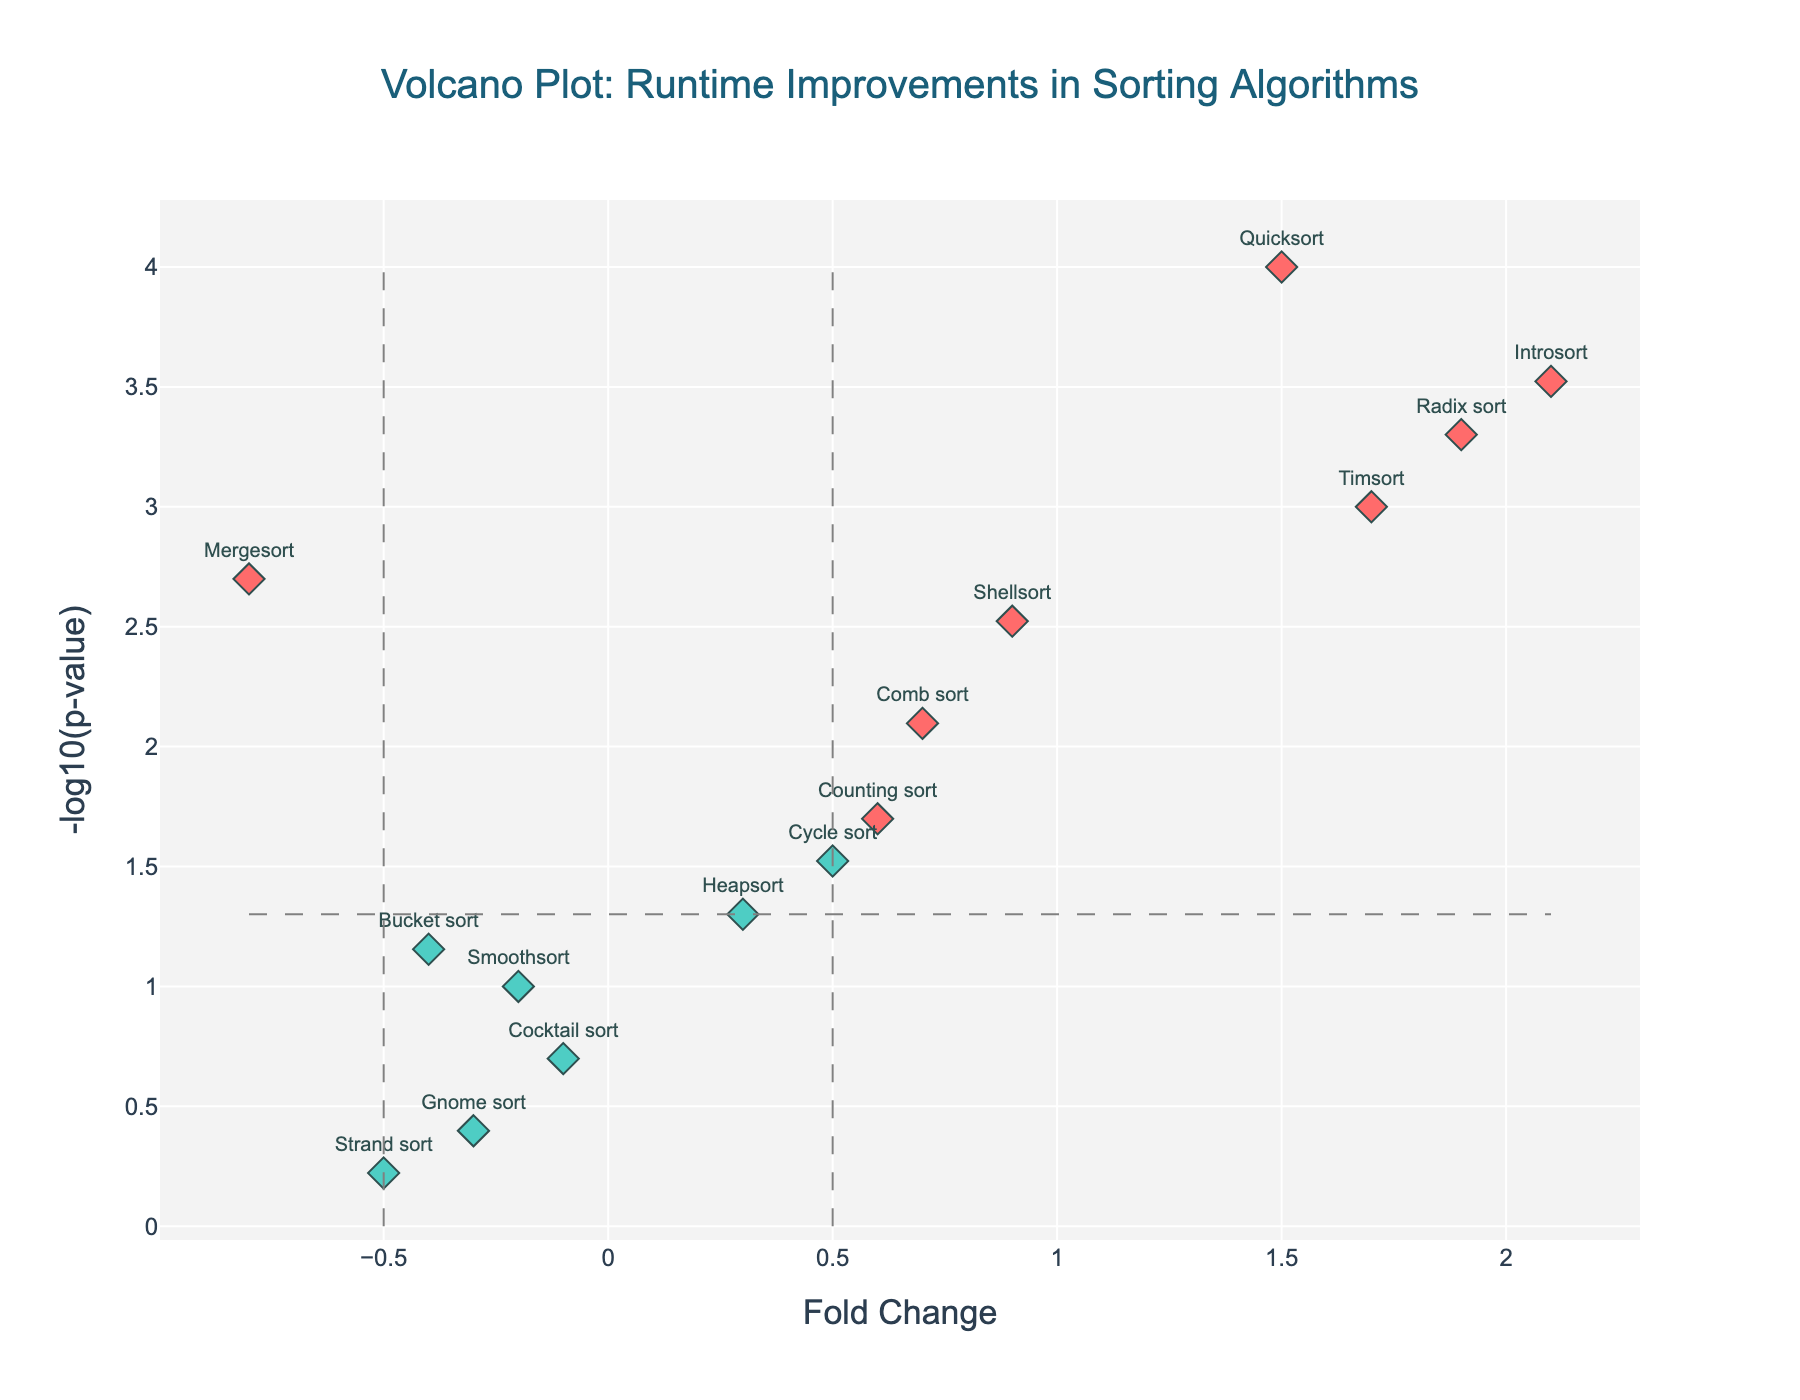What is the title of the figure? The title of the figure is displayed at the top and reads "Volcano Plot: Runtime Improvements in Sorting Algorithms".
Answer: Volcano Plot: Runtime Improvements in Sorting Algorithms What is shown on the x-axis and y-axis? The x-axis is labeled "Fold Change", which shows the change in algorithm run times. The y-axis is labeled "-log10(p-value)", indicating the statistical significance of those changes.
Answer: Fold Change and -log10(p-value) Which algorithm has the highest fold change? To determine this, we look at the scatter points and identify the algorithm with the highest x-axis value, which represents fold change.
Answer: Introsort How many algorithms are considered significant according to the plot? Algorithms are considered 'Significant' if their p-value is less than 0.05 and their absolute fold change is greater than 0.5. These points are color-coded in a distinct color. By counting these, we find there are 6 significant algorithms.
Answer: 6 Which has a more significant p-value, Counting sort or Shellsort? Compare the y-axis values (-log10(p-value)) of both algorithms. Shellsort has a higher y-axis value compared to Counting sort, indicating a more significant p-value.
Answer: Shellsort What fold change does Mergesort have and is it statistically significant? The x-axis (fold change) for Mergesort is -0.8. A fold change value below -0.5 can be significant if the p-value also meets the threshold. The p-value for Mergesort is 0.002, so it is statistically significant.
Answer: -0.8 and Yes Which algorithm has the lowest p-value? The lowest p-value is identified by the highest y-axis value (-log10(p-value)), which corresponds to the algorithm Quicksort.
Answer: Quicksort Which algorithm has the least significant p-value and what is its fold change? The least significant p-value corresponds to the lowest y-axis value, which is identified as the algorithm Strand sort. The fold change for Strand sort is -0.5.
Answer: Strand sort and -0.5 Compare the fold changes of Heapsort and Comb sort. Which one shows a higher improvement in runtime? By comparing their x-axis values, Comb sort has a fold change of 0.7, which is higher than Heapsort's 0.3, indicating a greater improvement in runtime for Comb sort.
Answer: Comb sort Are there any algorithms with a negative fold change that are also significant? A negative fold change indicates a runtime decrease. By looking at the color-coded points for significance, we see that Mergesort is both significant and has a negative fold change.
Answer: Mergesort 